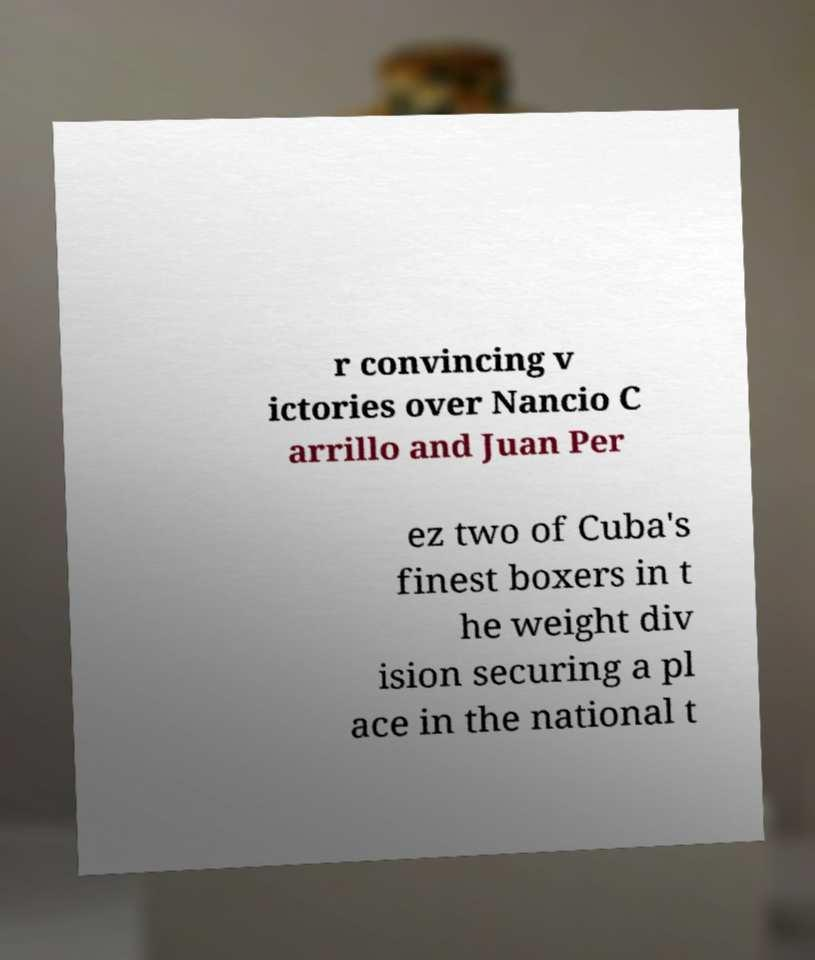Can you accurately transcribe the text from the provided image for me? r convincing v ictories over Nancio C arrillo and Juan Per ez two of Cuba's finest boxers in t he weight div ision securing a pl ace in the national t 